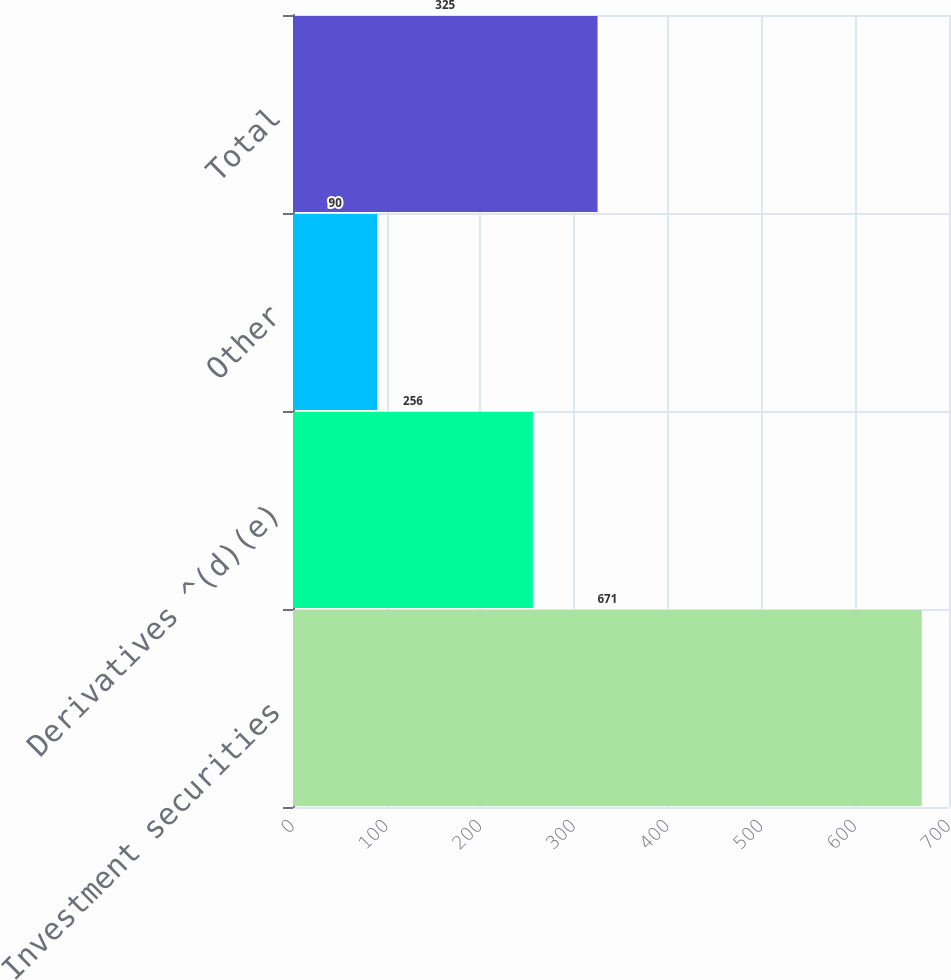<chart> <loc_0><loc_0><loc_500><loc_500><bar_chart><fcel>Investment securities<fcel>Derivatives ^(d)(e)<fcel>Other<fcel>Total<nl><fcel>671<fcel>256<fcel>90<fcel>325<nl></chart> 